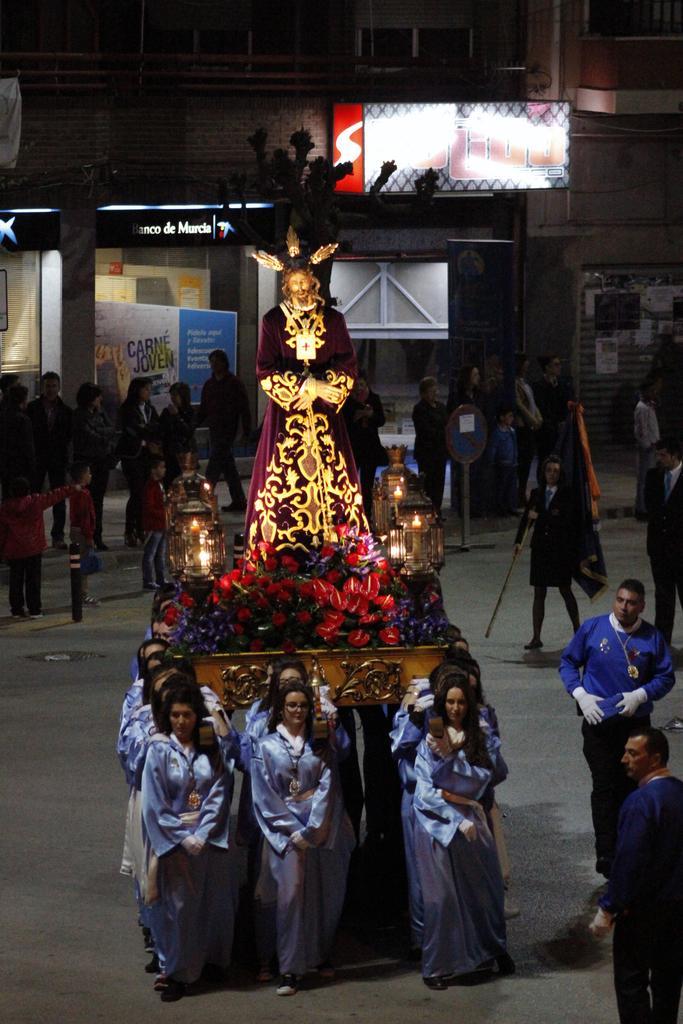In one or two sentences, can you explain what this image depicts? In this image we can see a group of people carrying the palanquin on which we can see a statue, some lamps and bouquets on it. We can also see a group of people standing on the ground. In that a man is holding the flag. On the backside we can see a signboard, a building with windows and the boards with some text on it. 